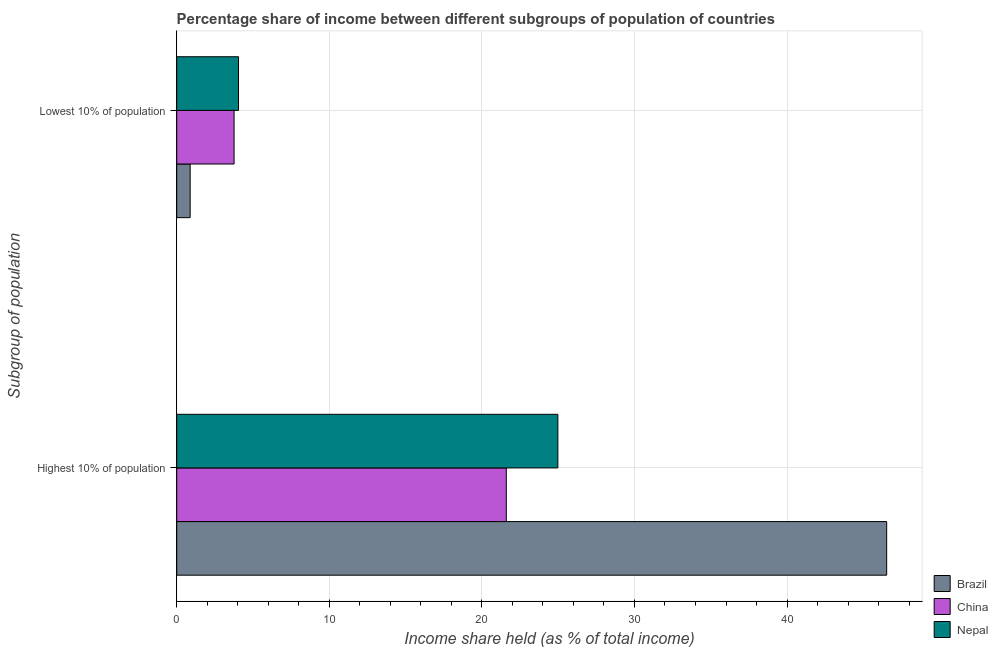How many different coloured bars are there?
Offer a very short reply. 3. How many bars are there on the 2nd tick from the top?
Give a very brief answer. 3. What is the label of the 1st group of bars from the top?
Offer a terse response. Lowest 10% of population. What is the income share held by highest 10% of the population in Nepal?
Your answer should be compact. 24.98. Across all countries, what is the maximum income share held by highest 10% of the population?
Keep it short and to the point. 46.53. Across all countries, what is the minimum income share held by lowest 10% of the population?
Provide a succinct answer. 0.88. In which country was the income share held by highest 10% of the population minimum?
Your answer should be compact. China. What is the total income share held by lowest 10% of the population in the graph?
Provide a succinct answer. 8.69. What is the difference between the income share held by highest 10% of the population in Brazil and that in Nepal?
Offer a terse response. 21.55. What is the difference between the income share held by highest 10% of the population in China and the income share held by lowest 10% of the population in Brazil?
Keep it short and to the point. 20.72. What is the average income share held by highest 10% of the population per country?
Keep it short and to the point. 31.04. What is the difference between the income share held by lowest 10% of the population and income share held by highest 10% of the population in Brazil?
Offer a very short reply. -45.65. In how many countries, is the income share held by highest 10% of the population greater than 40 %?
Your response must be concise. 1. What is the ratio of the income share held by highest 10% of the population in Nepal to that in China?
Your answer should be very brief. 1.16. What does the 1st bar from the top in Lowest 10% of population represents?
Ensure brevity in your answer.  Nepal. How many countries are there in the graph?
Provide a succinct answer. 3. What is the difference between two consecutive major ticks on the X-axis?
Make the answer very short. 10. Are the values on the major ticks of X-axis written in scientific E-notation?
Ensure brevity in your answer.  No. How many legend labels are there?
Provide a short and direct response. 3. What is the title of the graph?
Offer a terse response. Percentage share of income between different subgroups of population of countries. Does "Middle income" appear as one of the legend labels in the graph?
Offer a terse response. No. What is the label or title of the X-axis?
Provide a succinct answer. Income share held (as % of total income). What is the label or title of the Y-axis?
Offer a very short reply. Subgroup of population. What is the Income share held (as % of total income) of Brazil in Highest 10% of population?
Offer a terse response. 46.53. What is the Income share held (as % of total income) of China in Highest 10% of population?
Offer a terse response. 21.6. What is the Income share held (as % of total income) in Nepal in Highest 10% of population?
Give a very brief answer. 24.98. What is the Income share held (as % of total income) in Brazil in Lowest 10% of population?
Ensure brevity in your answer.  0.88. What is the Income share held (as % of total income) in China in Lowest 10% of population?
Your answer should be compact. 3.76. What is the Income share held (as % of total income) of Nepal in Lowest 10% of population?
Offer a terse response. 4.05. Across all Subgroup of population, what is the maximum Income share held (as % of total income) in Brazil?
Ensure brevity in your answer.  46.53. Across all Subgroup of population, what is the maximum Income share held (as % of total income) in China?
Offer a very short reply. 21.6. Across all Subgroup of population, what is the maximum Income share held (as % of total income) of Nepal?
Your answer should be compact. 24.98. Across all Subgroup of population, what is the minimum Income share held (as % of total income) in China?
Your response must be concise. 3.76. Across all Subgroup of population, what is the minimum Income share held (as % of total income) of Nepal?
Offer a very short reply. 4.05. What is the total Income share held (as % of total income) of Brazil in the graph?
Keep it short and to the point. 47.41. What is the total Income share held (as % of total income) in China in the graph?
Give a very brief answer. 25.36. What is the total Income share held (as % of total income) in Nepal in the graph?
Give a very brief answer. 29.03. What is the difference between the Income share held (as % of total income) of Brazil in Highest 10% of population and that in Lowest 10% of population?
Make the answer very short. 45.65. What is the difference between the Income share held (as % of total income) of China in Highest 10% of population and that in Lowest 10% of population?
Your answer should be compact. 17.84. What is the difference between the Income share held (as % of total income) of Nepal in Highest 10% of population and that in Lowest 10% of population?
Ensure brevity in your answer.  20.93. What is the difference between the Income share held (as % of total income) of Brazil in Highest 10% of population and the Income share held (as % of total income) of China in Lowest 10% of population?
Your answer should be compact. 42.77. What is the difference between the Income share held (as % of total income) in Brazil in Highest 10% of population and the Income share held (as % of total income) in Nepal in Lowest 10% of population?
Provide a succinct answer. 42.48. What is the difference between the Income share held (as % of total income) in China in Highest 10% of population and the Income share held (as % of total income) in Nepal in Lowest 10% of population?
Give a very brief answer. 17.55. What is the average Income share held (as % of total income) of Brazil per Subgroup of population?
Make the answer very short. 23.7. What is the average Income share held (as % of total income) of China per Subgroup of population?
Make the answer very short. 12.68. What is the average Income share held (as % of total income) in Nepal per Subgroup of population?
Give a very brief answer. 14.52. What is the difference between the Income share held (as % of total income) of Brazil and Income share held (as % of total income) of China in Highest 10% of population?
Your answer should be very brief. 24.93. What is the difference between the Income share held (as % of total income) in Brazil and Income share held (as % of total income) in Nepal in Highest 10% of population?
Your response must be concise. 21.55. What is the difference between the Income share held (as % of total income) in China and Income share held (as % of total income) in Nepal in Highest 10% of population?
Give a very brief answer. -3.38. What is the difference between the Income share held (as % of total income) of Brazil and Income share held (as % of total income) of China in Lowest 10% of population?
Give a very brief answer. -2.88. What is the difference between the Income share held (as % of total income) in Brazil and Income share held (as % of total income) in Nepal in Lowest 10% of population?
Keep it short and to the point. -3.17. What is the difference between the Income share held (as % of total income) of China and Income share held (as % of total income) of Nepal in Lowest 10% of population?
Make the answer very short. -0.29. What is the ratio of the Income share held (as % of total income) of Brazil in Highest 10% of population to that in Lowest 10% of population?
Give a very brief answer. 52.88. What is the ratio of the Income share held (as % of total income) in China in Highest 10% of population to that in Lowest 10% of population?
Make the answer very short. 5.74. What is the ratio of the Income share held (as % of total income) of Nepal in Highest 10% of population to that in Lowest 10% of population?
Offer a terse response. 6.17. What is the difference between the highest and the second highest Income share held (as % of total income) of Brazil?
Ensure brevity in your answer.  45.65. What is the difference between the highest and the second highest Income share held (as % of total income) in China?
Ensure brevity in your answer.  17.84. What is the difference between the highest and the second highest Income share held (as % of total income) in Nepal?
Give a very brief answer. 20.93. What is the difference between the highest and the lowest Income share held (as % of total income) in Brazil?
Ensure brevity in your answer.  45.65. What is the difference between the highest and the lowest Income share held (as % of total income) of China?
Give a very brief answer. 17.84. What is the difference between the highest and the lowest Income share held (as % of total income) in Nepal?
Ensure brevity in your answer.  20.93. 